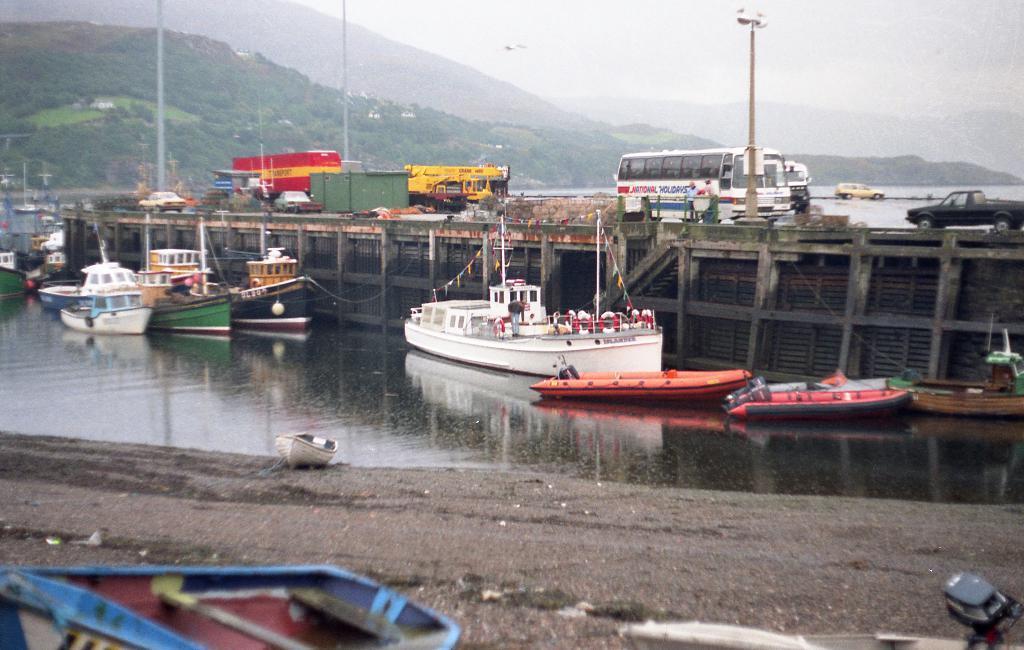How would you summarize this image in a sentence or two? In this picture we can see water, there are some boats in the water, on the right side there is a bridge, we can see some vehicles on the bridge, in the background there are some poles and trees, we can see soil at the bottom. 